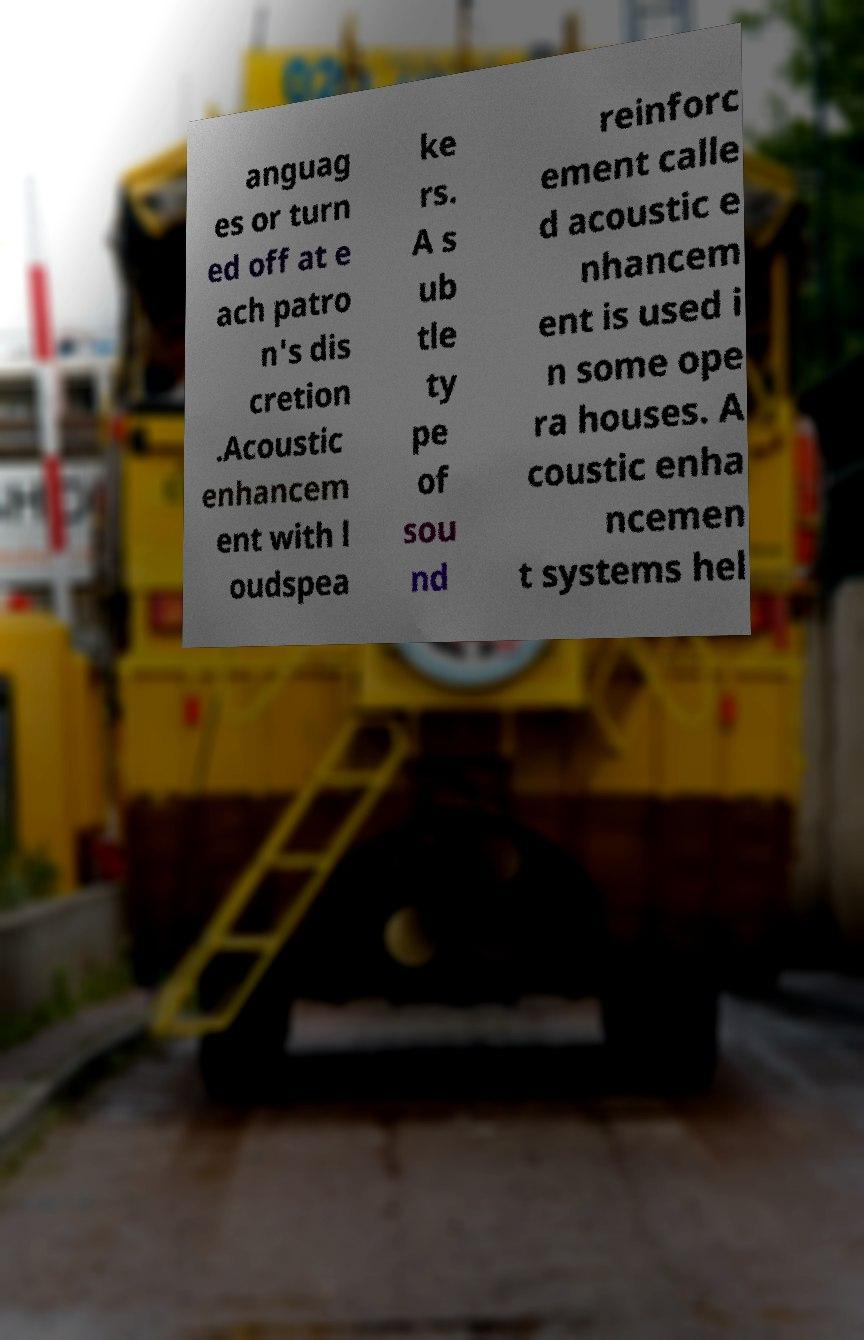What messages or text are displayed in this image? I need them in a readable, typed format. anguag es or turn ed off at e ach patro n's dis cretion .Acoustic enhancem ent with l oudspea ke rs. A s ub tle ty pe of sou nd reinforc ement calle d acoustic e nhancem ent is used i n some ope ra houses. A coustic enha ncemen t systems hel 